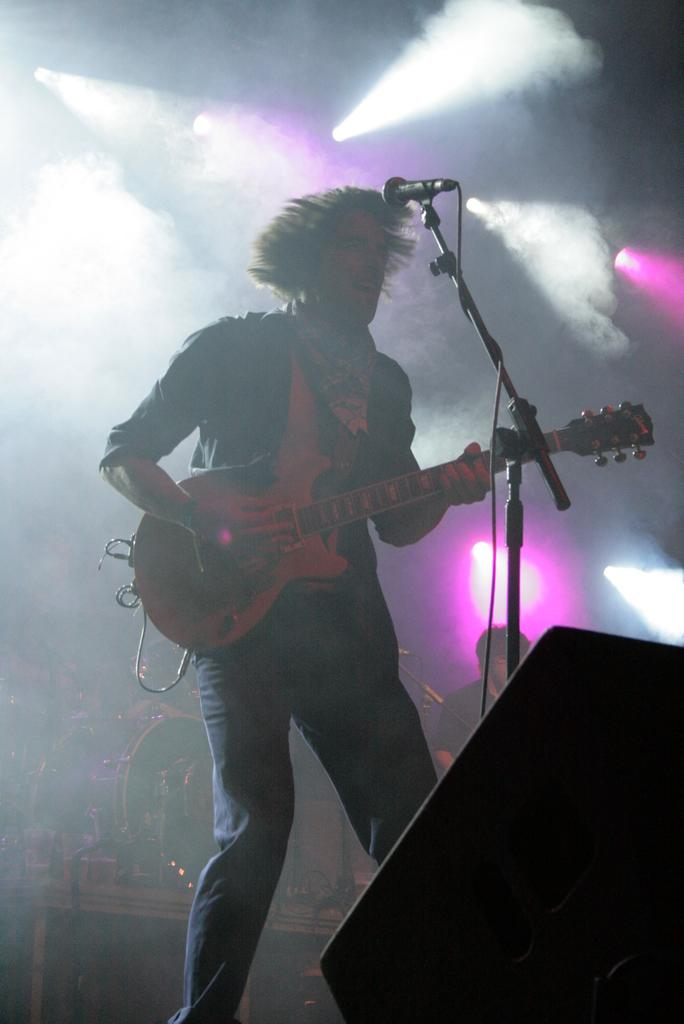What is the person in the image holding? The person is holding a guitar. What object is in front of the person? There is a microphone with a stand in front of the person. Can you describe the other person in the image? There is another person standing in the background. What type of kettle is being used by the person playing the guitar in the image? There is no kettle present in the image; the person is holding a guitar and standing near a microphone with a stand. 